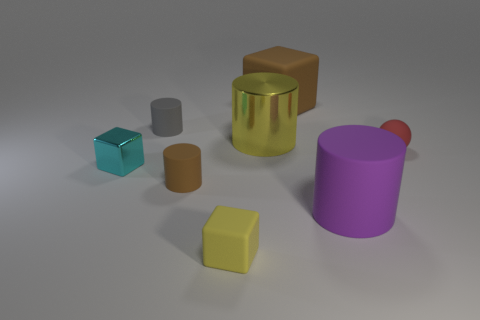Add 1 small rubber cylinders. How many objects exist? 9 Subtract all big shiny cylinders. How many cylinders are left? 3 Subtract all brown cubes. How many cubes are left? 2 Subtract 1 cubes. How many cubes are left? 2 Subtract all blocks. How many objects are left? 5 Subtract all red cylinders. Subtract all blue cubes. How many cylinders are left? 4 Subtract all brown cylinders. How many gray cubes are left? 0 Add 4 gray rubber objects. How many gray rubber objects exist? 5 Subtract 0 green cubes. How many objects are left? 8 Subtract all large purple rubber spheres. Subtract all small rubber objects. How many objects are left? 4 